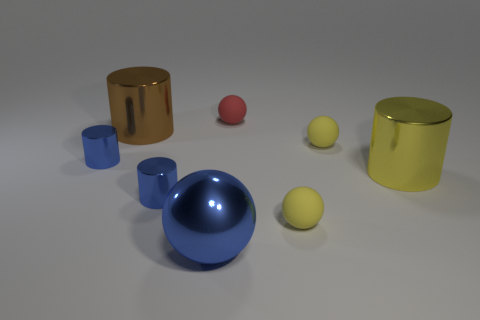Subtract 1 balls. How many balls are left? 3 Add 1 red balls. How many objects exist? 9 Subtract 0 red blocks. How many objects are left? 8 Subtract all yellow matte balls. Subtract all small rubber spheres. How many objects are left? 3 Add 2 rubber balls. How many rubber balls are left? 5 Add 5 blue metal cylinders. How many blue metal cylinders exist? 7 